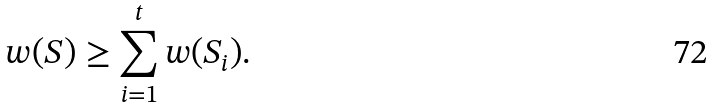<formula> <loc_0><loc_0><loc_500><loc_500>w ( S ) \geq \sum _ { i = 1 } ^ { t } w ( S _ { i } ) .</formula> 